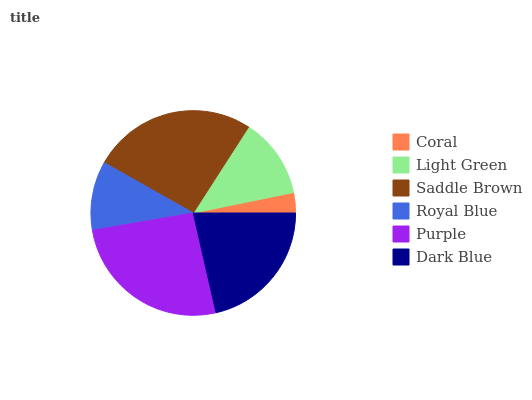Is Coral the minimum?
Answer yes or no. Yes. Is Saddle Brown the maximum?
Answer yes or no. Yes. Is Light Green the minimum?
Answer yes or no. No. Is Light Green the maximum?
Answer yes or no. No. Is Light Green greater than Coral?
Answer yes or no. Yes. Is Coral less than Light Green?
Answer yes or no. Yes. Is Coral greater than Light Green?
Answer yes or no. No. Is Light Green less than Coral?
Answer yes or no. No. Is Dark Blue the high median?
Answer yes or no. Yes. Is Light Green the low median?
Answer yes or no. Yes. Is Royal Blue the high median?
Answer yes or no. No. Is Royal Blue the low median?
Answer yes or no. No. 